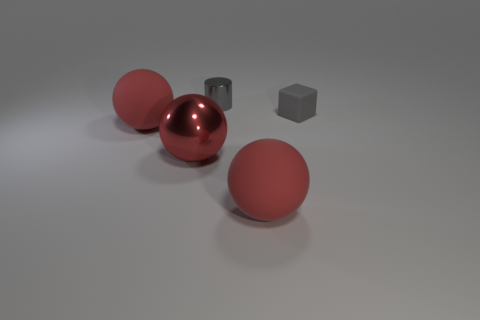What is the shape of the tiny thing in front of the small thing behind the gray block?
Keep it short and to the point. Cube. There is a red metal thing; is its size the same as the red matte ball that is to the left of the small shiny cylinder?
Your answer should be compact. Yes. There is a big thing left of the shiny sphere; what material is it?
Offer a very short reply. Rubber. What number of objects are both behind the tiny matte object and in front of the big metallic object?
Your answer should be very brief. 0. What is the material of the cylinder that is the same size as the gray block?
Ensure brevity in your answer.  Metal. There is a metallic thing that is in front of the gray rubber object; is it the same size as the red matte object that is on the right side of the big red metallic sphere?
Offer a terse response. Yes. Are there any large things behind the block?
Give a very brief answer. No. There is a big matte ball right of the large red matte ball that is to the left of the big metallic thing; what is its color?
Provide a short and direct response. Red. Are there fewer small matte cubes than small green metallic things?
Offer a terse response. No. How many other large red things are the same shape as the big red metallic thing?
Provide a succinct answer. 2. 